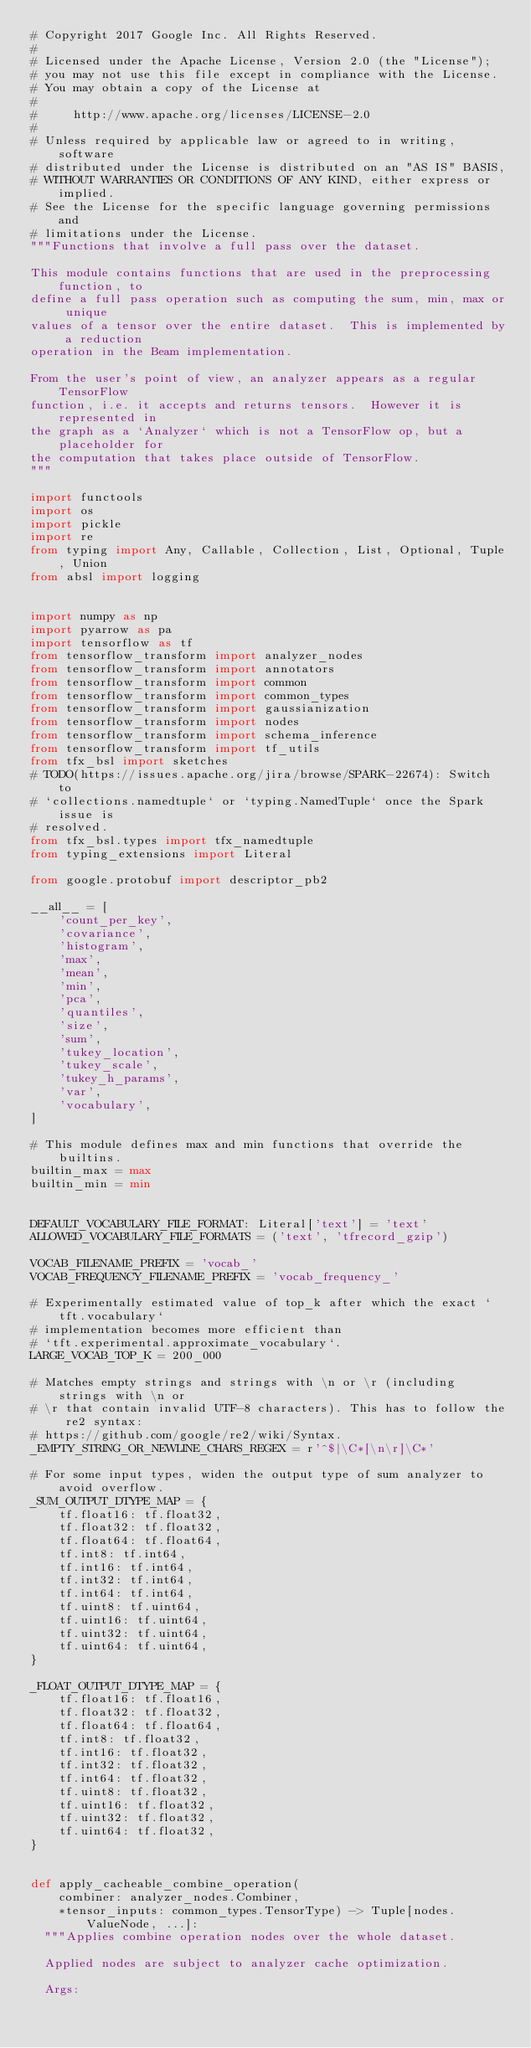Convert code to text. <code><loc_0><loc_0><loc_500><loc_500><_Python_># Copyright 2017 Google Inc. All Rights Reserved.
#
# Licensed under the Apache License, Version 2.0 (the "License");
# you may not use this file except in compliance with the License.
# You may obtain a copy of the License at
#
#     http://www.apache.org/licenses/LICENSE-2.0
#
# Unless required by applicable law or agreed to in writing, software
# distributed under the License is distributed on an "AS IS" BASIS,
# WITHOUT WARRANTIES OR CONDITIONS OF ANY KIND, either express or implied.
# See the License for the specific language governing permissions and
# limitations under the License.
"""Functions that involve a full pass over the dataset.

This module contains functions that are used in the preprocessing function, to
define a full pass operation such as computing the sum, min, max or unique
values of a tensor over the entire dataset.  This is implemented by a reduction
operation in the Beam implementation.

From the user's point of view, an analyzer appears as a regular TensorFlow
function, i.e. it accepts and returns tensors.  However it is represented in
the graph as a `Analyzer` which is not a TensorFlow op, but a placeholder for
the computation that takes place outside of TensorFlow.
"""

import functools
import os
import pickle
import re
from typing import Any, Callable, Collection, List, Optional, Tuple, Union
from absl import logging


import numpy as np
import pyarrow as pa
import tensorflow as tf
from tensorflow_transform import analyzer_nodes
from tensorflow_transform import annotators
from tensorflow_transform import common
from tensorflow_transform import common_types
from tensorflow_transform import gaussianization
from tensorflow_transform import nodes
from tensorflow_transform import schema_inference
from tensorflow_transform import tf_utils
from tfx_bsl import sketches
# TODO(https://issues.apache.org/jira/browse/SPARK-22674): Switch to
# `collections.namedtuple` or `typing.NamedTuple` once the Spark issue is
# resolved.
from tfx_bsl.types import tfx_namedtuple
from typing_extensions import Literal

from google.protobuf import descriptor_pb2

__all__ = [
    'count_per_key',
    'covariance',
    'histogram',
    'max',
    'mean',
    'min',
    'pca',
    'quantiles',
    'size',
    'sum',
    'tukey_location',
    'tukey_scale',
    'tukey_h_params',
    'var',
    'vocabulary',
]

# This module defines max and min functions that override the builtins.
builtin_max = max
builtin_min = min


DEFAULT_VOCABULARY_FILE_FORMAT: Literal['text'] = 'text'
ALLOWED_VOCABULARY_FILE_FORMATS = ('text', 'tfrecord_gzip')

VOCAB_FILENAME_PREFIX = 'vocab_'
VOCAB_FREQUENCY_FILENAME_PREFIX = 'vocab_frequency_'

# Experimentally estimated value of top_k after which the exact `tft.vocabulary`
# implementation becomes more efficient than
# `tft.experimental.approximate_vocabulary`.
LARGE_VOCAB_TOP_K = 200_000

# Matches empty strings and strings with \n or \r (including strings with \n or
# \r that contain invalid UTF-8 characters). This has to follow the re2 syntax:
# https://github.com/google/re2/wiki/Syntax.
_EMPTY_STRING_OR_NEWLINE_CHARS_REGEX = r'^$|\C*[\n\r]\C*'

# For some input types, widen the output type of sum analyzer to avoid overflow.
_SUM_OUTPUT_DTYPE_MAP = {
    tf.float16: tf.float32,
    tf.float32: tf.float32,
    tf.float64: tf.float64,
    tf.int8: tf.int64,
    tf.int16: tf.int64,
    tf.int32: tf.int64,
    tf.int64: tf.int64,
    tf.uint8: tf.uint64,
    tf.uint16: tf.uint64,
    tf.uint32: tf.uint64,
    tf.uint64: tf.uint64,
}

_FLOAT_OUTPUT_DTYPE_MAP = {
    tf.float16: tf.float16,
    tf.float32: tf.float32,
    tf.float64: tf.float64,
    tf.int8: tf.float32,
    tf.int16: tf.float32,
    tf.int32: tf.float32,
    tf.int64: tf.float32,
    tf.uint8: tf.float32,
    tf.uint16: tf.float32,
    tf.uint32: tf.float32,
    tf.uint64: tf.float32,
}


def apply_cacheable_combine_operation(
    combiner: analyzer_nodes.Combiner,
    *tensor_inputs: common_types.TensorType) -> Tuple[nodes.ValueNode, ...]:
  """Applies combine operation nodes over the whole dataset.

  Applied nodes are subject to analyzer cache optimization.

  Args:</code> 